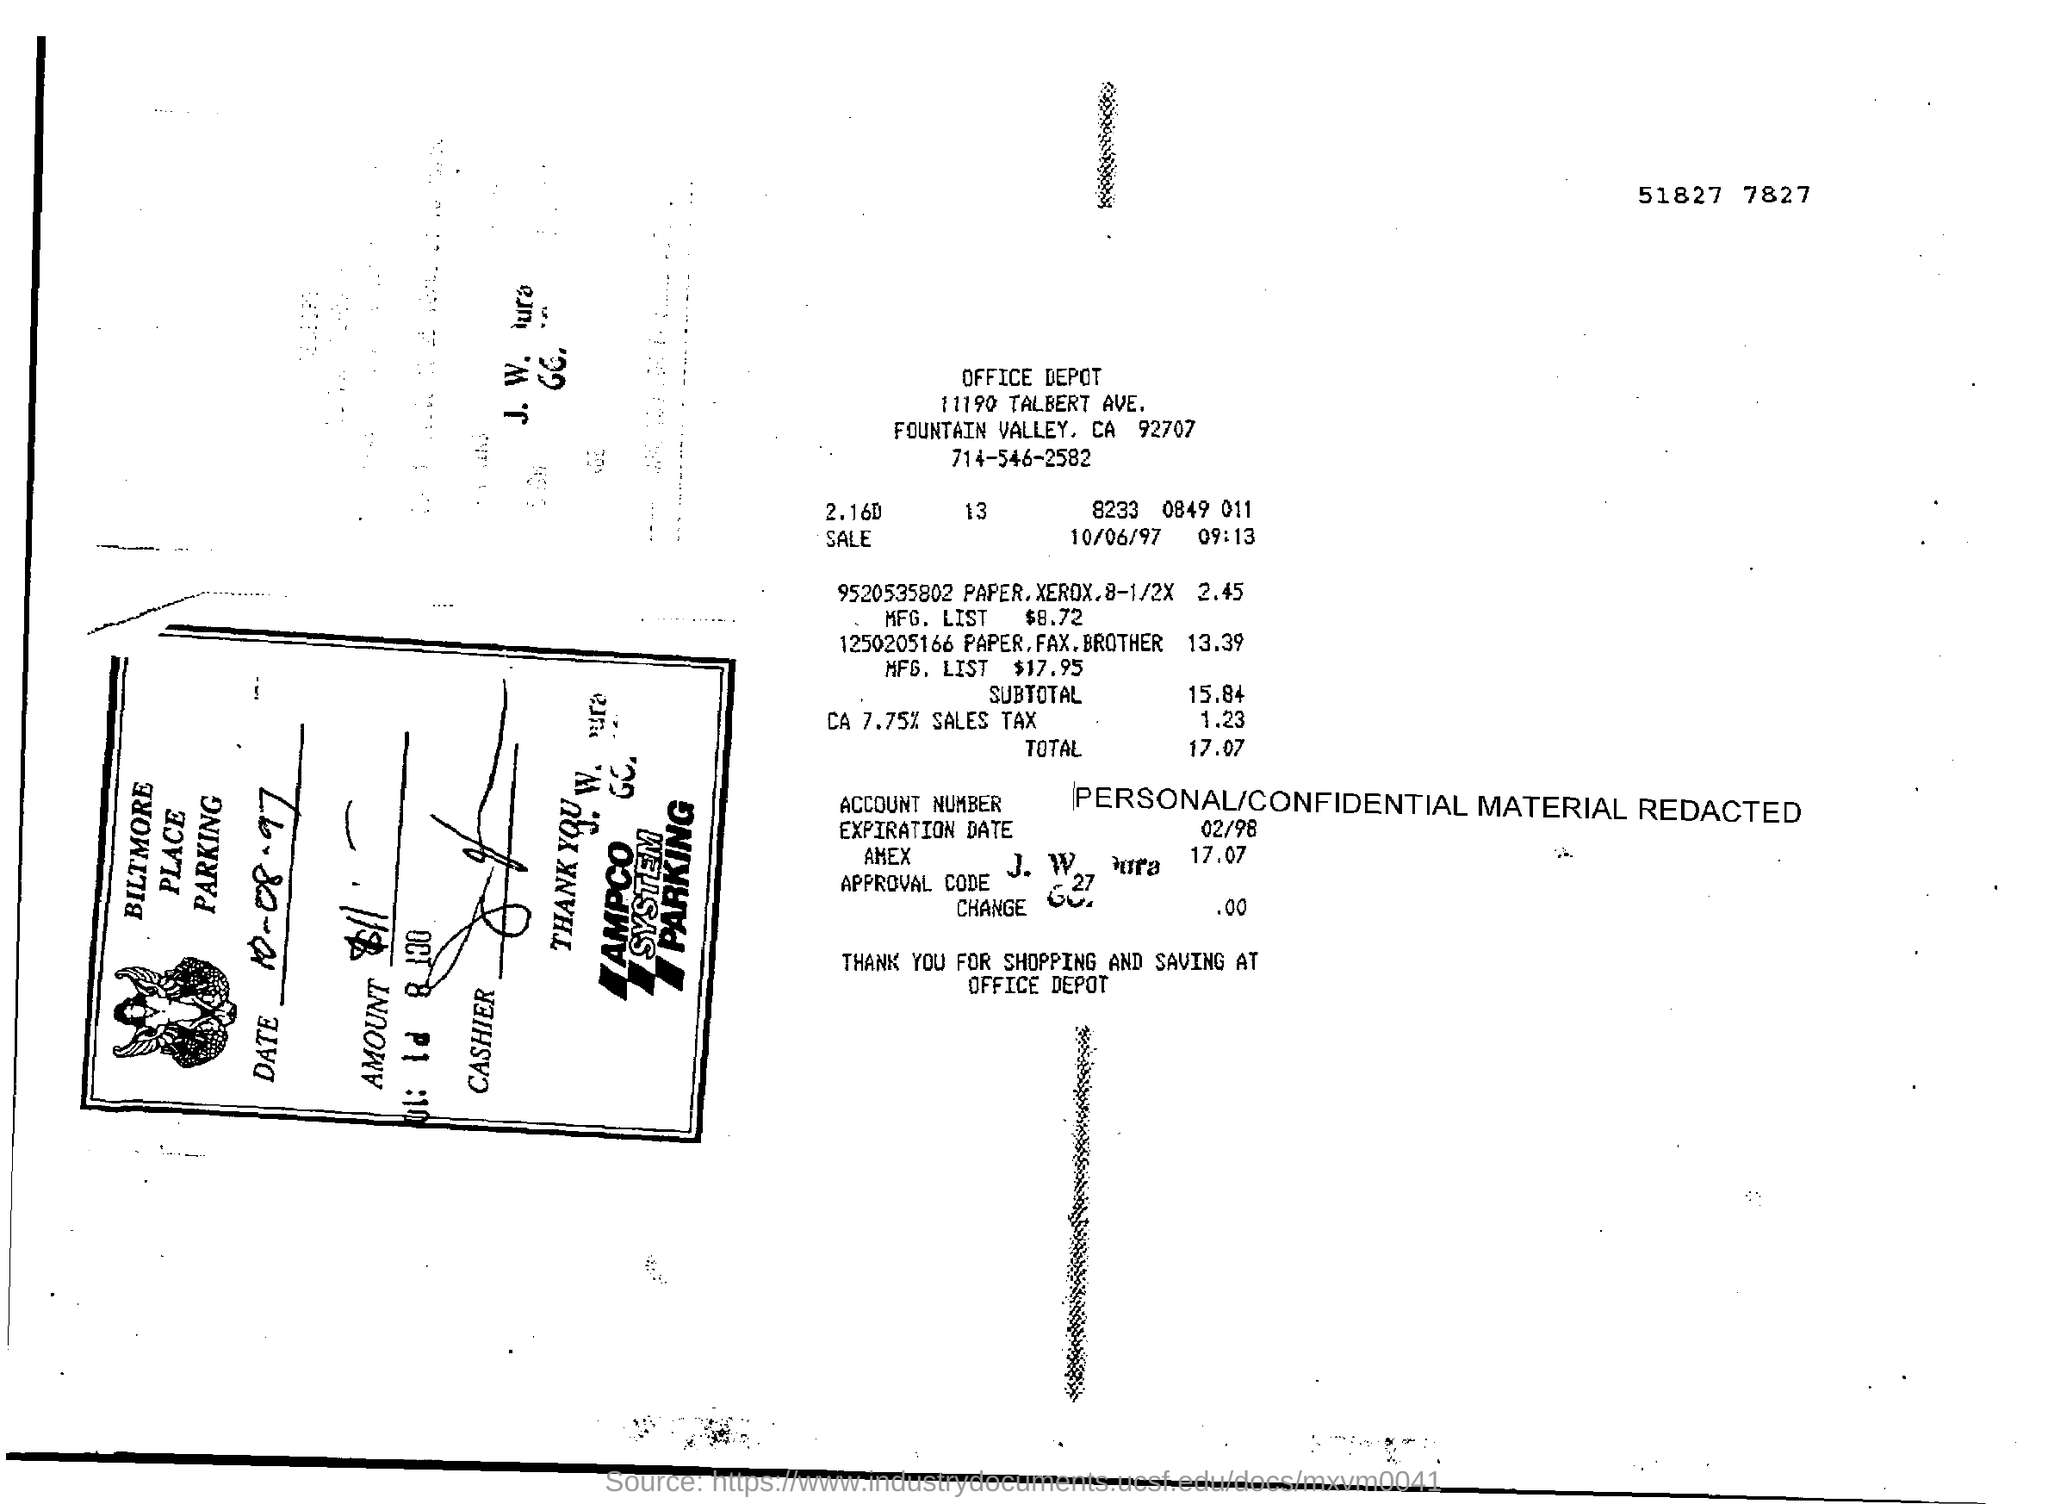How much is the total ?
Provide a succinct answer. 17.07. 